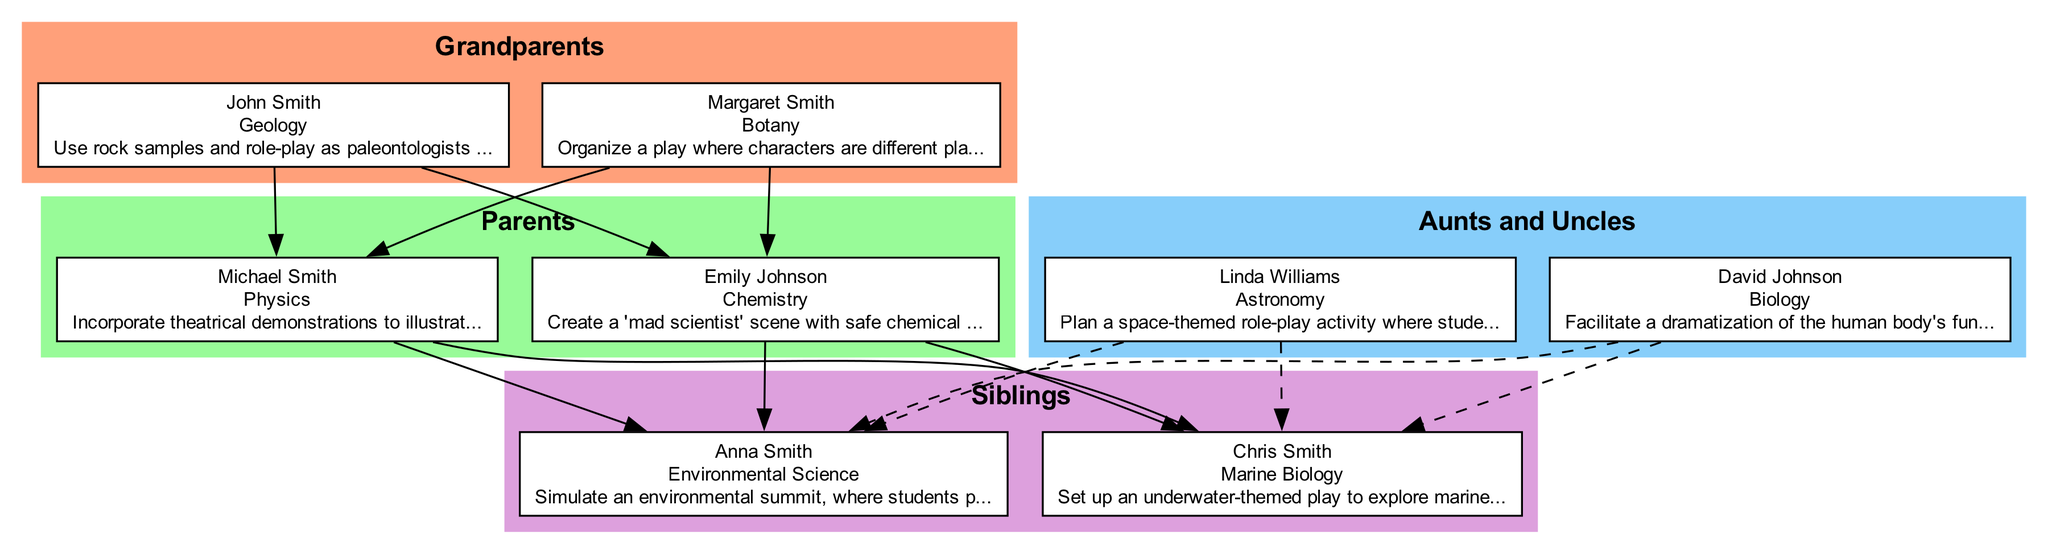What is the branch of science that John Smith specializes in? John Smith is listed under the "Grandparents" category, and his node indicates the branch of science as "Geology."
Answer: Geology How many family members are listed in the "Parents" section? The "Parents" section has two members: Michael Smith and Emily Johnson. Thus, the total is two.
Answer: 2 Which family member covers the branch of Marine Biology? Siblings section contains Chris Smith, who is associated with the branch of science "Marine Biology."
Answer: Chris Smith Which branch of science is linked to David Johnson? David Johnson belongs to the "Aunts and Uncles" category and is linked to the branch of science "Biology."
Answer: Biology What is the relationship between Linda Williams and Michael Smith? Linda Williams is categorized under "Aunts and Uncles," while Michael Smith is in "Parents." There is a direct familial connection as aunt/uncle to parent.
Answer: Aunt/Uncle How many connections (edges) are there between grandparents and parents? Each grandparent is connected to each parent, resulting in a total of four connections: John Smith to Michael Smith, John Smith to Emily Johnson, Margaret Smith to Michael Smith, and Margaret Smith to Emily Johnson.
Answer: 4 What is Anna Smith's role in the Environmental Science branch? Anna Smith is categorized under "Siblings" and is specified to cover "Environmental Science," implying her role in that branch specifically.
Answer: Environmental Science Which family member's drama tip involves a space-themed activity? The drama tip associated with space-themed activities pertains to Linda Williams, who covers Astronomy.
Answer: Linda Williams Which generation does Emily Johnson belong to? Emily Johnson is listed in the "Parents" section, indicating her generation is one generation above the "Siblings" and one generation below the "Grandparents."
Answer: Parents 